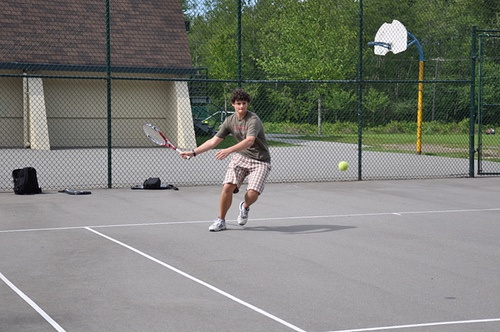Describe the objects in this image and their specific colors. I can see people in gray, darkgray, lightgray, and black tones, backpack in gray, black, and darkgray tones, tennis racket in gray, darkgray, lightgray, and brown tones, backpack in gray, black, and darkgray tones, and handbag in gray, black, and darkgray tones in this image. 